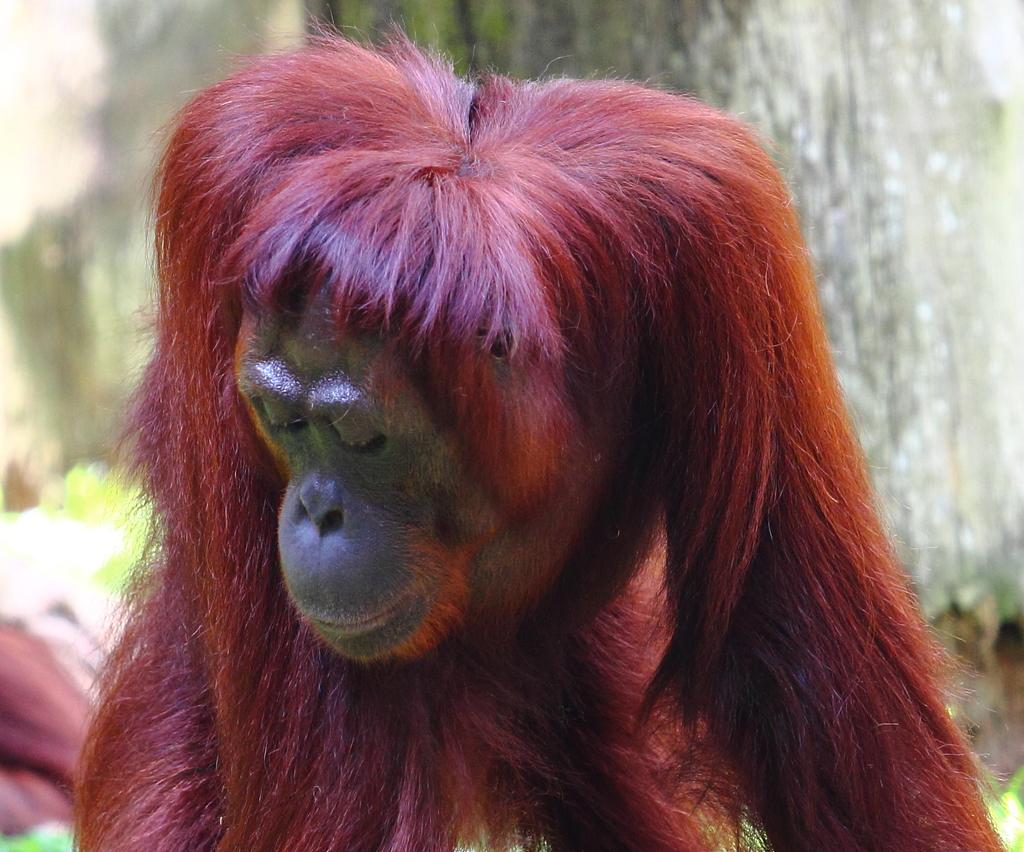What type of living creature is present in the image? There is an animal in the image. What other object can be seen in the image besides the animal? There is a tree trunk in the image. How does the animal change its color in the image? The animal does not change its color in the image; there is no indication of color-changing abilities. 